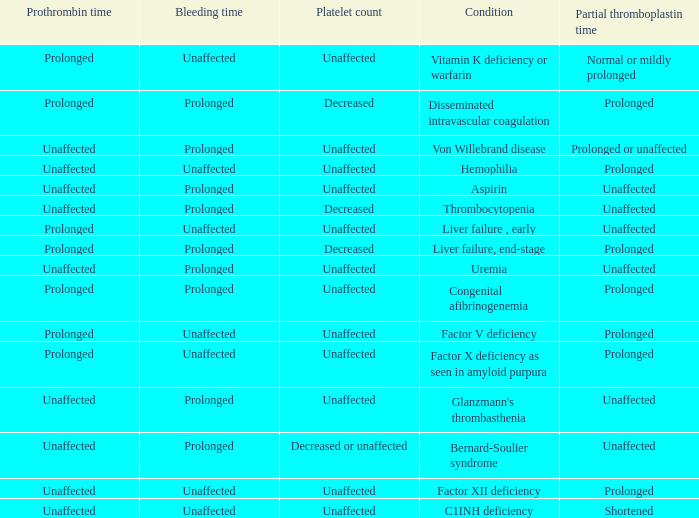Which Condition has a Bleeding time of unaffected, and a Partial thromboplastin time of prolonged, and a Prothrombin time of unaffected? Hemophilia, Factor XII deficiency. 